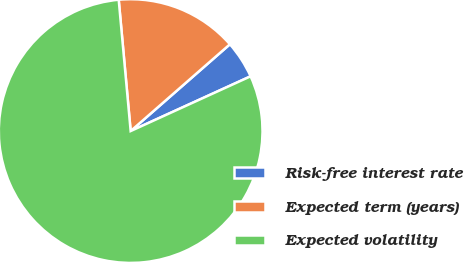Convert chart to OTSL. <chart><loc_0><loc_0><loc_500><loc_500><pie_chart><fcel>Risk-free interest rate<fcel>Expected term (years)<fcel>Expected volatility<nl><fcel>4.62%<fcel>15.01%<fcel>80.37%<nl></chart> 